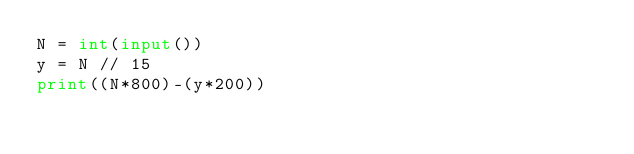<code> <loc_0><loc_0><loc_500><loc_500><_Python_>N = int(input())
y = N // 15
print((N*800)-(y*200))</code> 